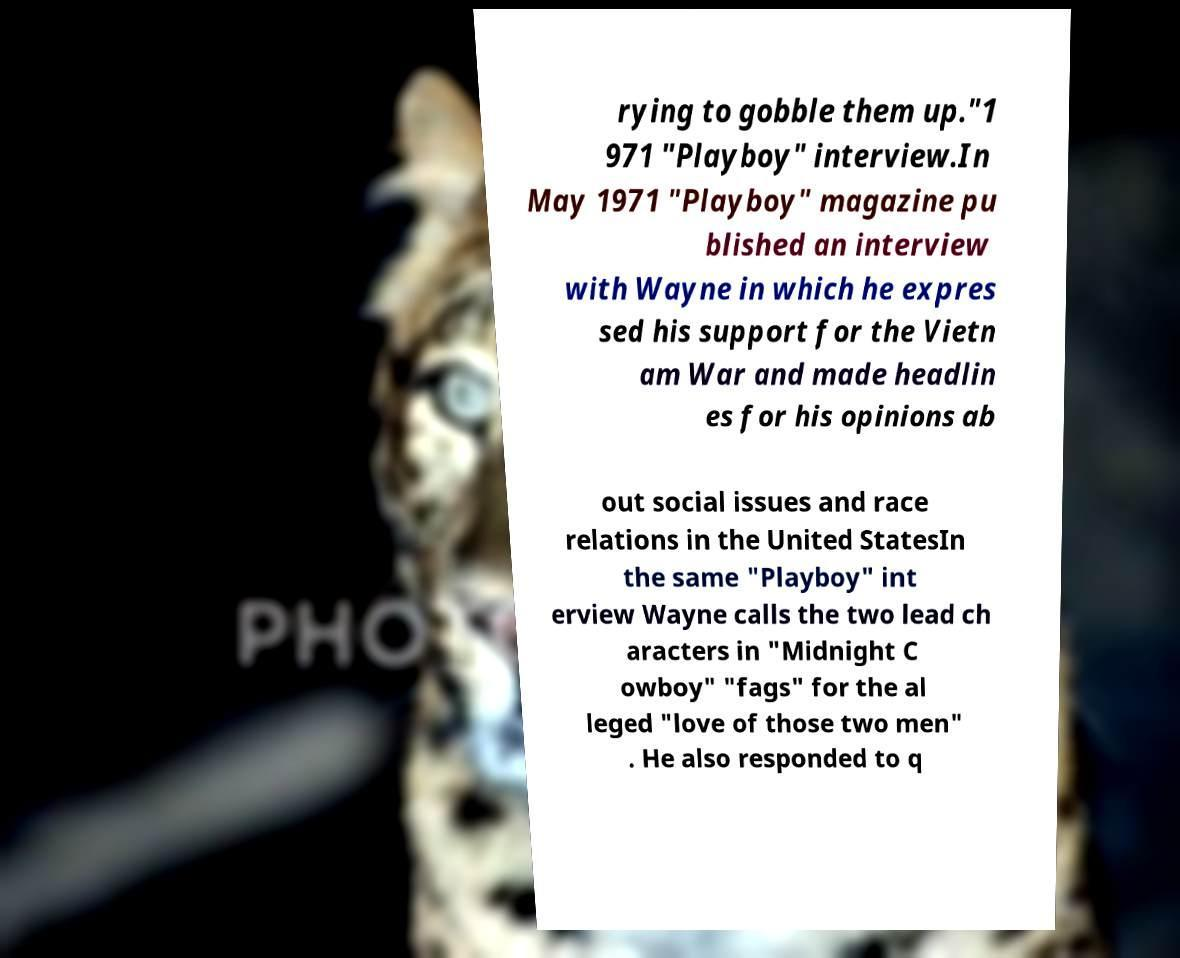What messages or text are displayed in this image? I need them in a readable, typed format. rying to gobble them up."1 971 "Playboy" interview.In May 1971 "Playboy" magazine pu blished an interview with Wayne in which he expres sed his support for the Vietn am War and made headlin es for his opinions ab out social issues and race relations in the United StatesIn the same "Playboy" int erview Wayne calls the two lead ch aracters in "Midnight C owboy" "fags" for the al leged "love of those two men" . He also responded to q 